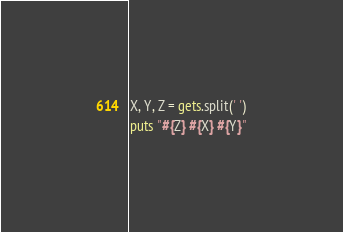<code> <loc_0><loc_0><loc_500><loc_500><_Ruby_>X, Y, Z = gets.split(' ')
puts "#{Z} #{X} #{Y}"</code> 